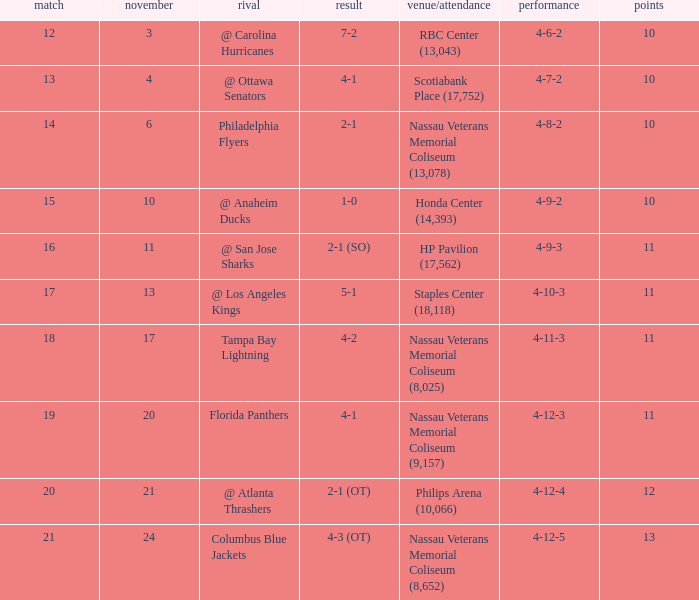What is the least entry for game if the score is 1-0? 15.0. 